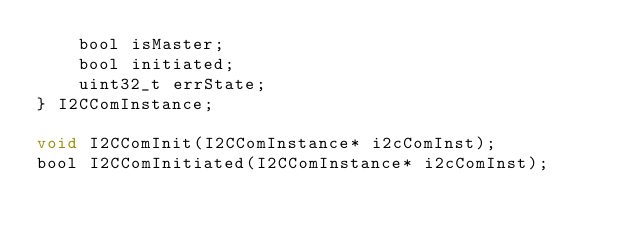Convert code to text. <code><loc_0><loc_0><loc_500><loc_500><_C_>    bool isMaster;
    bool initiated;
    uint32_t errState;
} I2CComInstance;

void I2CComInit(I2CComInstance* i2cComInst);
bool I2CComInitiated(I2CComInstance* i2cComInst);</code> 